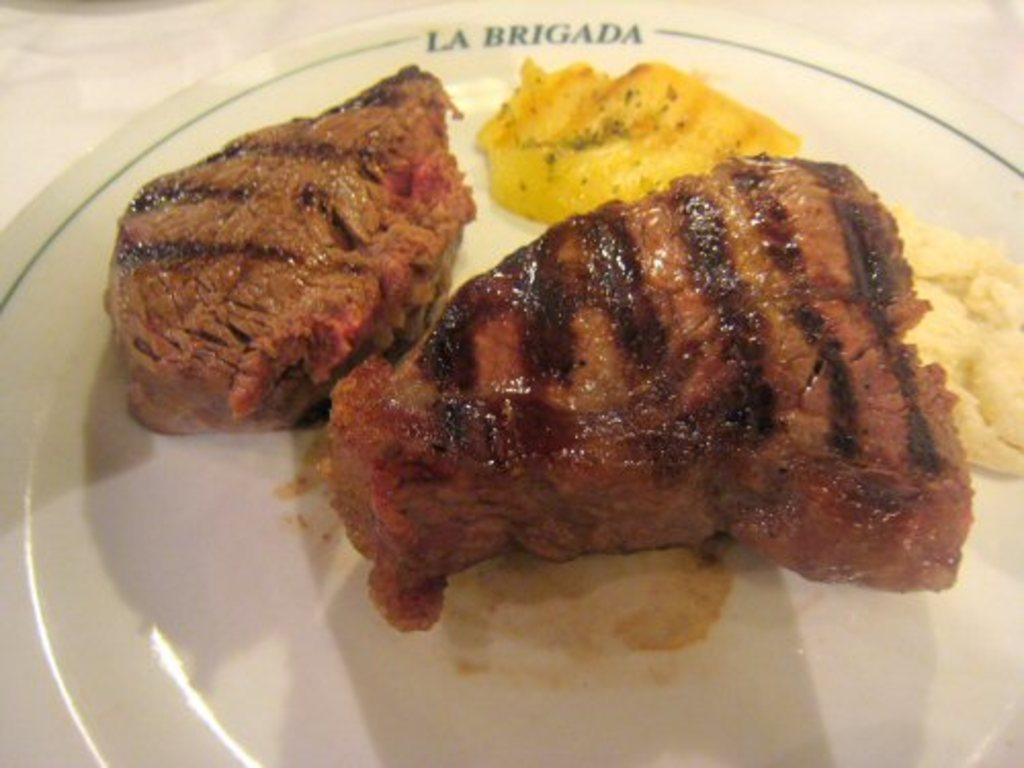Could you give a brief overview of what you see in this image? In the picture we can see food on the plate which is on a platform. 